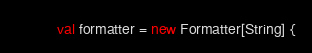<code> <loc_0><loc_0><loc_500><loc_500><_Scala_>          val formatter = new Formatter[String] {</code> 